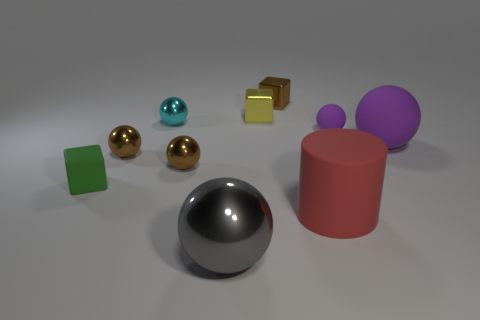Subtract 2 balls. How many balls are left? 4 Subtract all large gray balls. How many balls are left? 5 Subtract all cyan spheres. How many spheres are left? 5 Subtract all green spheres. Subtract all red cylinders. How many spheres are left? 6 Subtract all balls. How many objects are left? 4 Subtract 0 red balls. How many objects are left? 10 Subtract all large cyan matte balls. Subtract all small purple rubber balls. How many objects are left? 9 Add 7 yellow metallic things. How many yellow metallic things are left? 8 Add 3 tiny cubes. How many tiny cubes exist? 6 